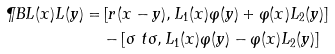<formula> <loc_0><loc_0><loc_500><loc_500>\P B { L ( x ) } { L ( y ) } = & \left [ r ( x - y ) , L _ { 1 } ( x ) \varphi ( y ) + \varphi ( x ) L _ { 2 } ( y ) \right ] \\ & - \left [ \sigma \ t \sigma , L _ { 1 } ( x ) \varphi ( y ) - \varphi ( x ) L _ { 2 } ( y ) \right ]</formula> 